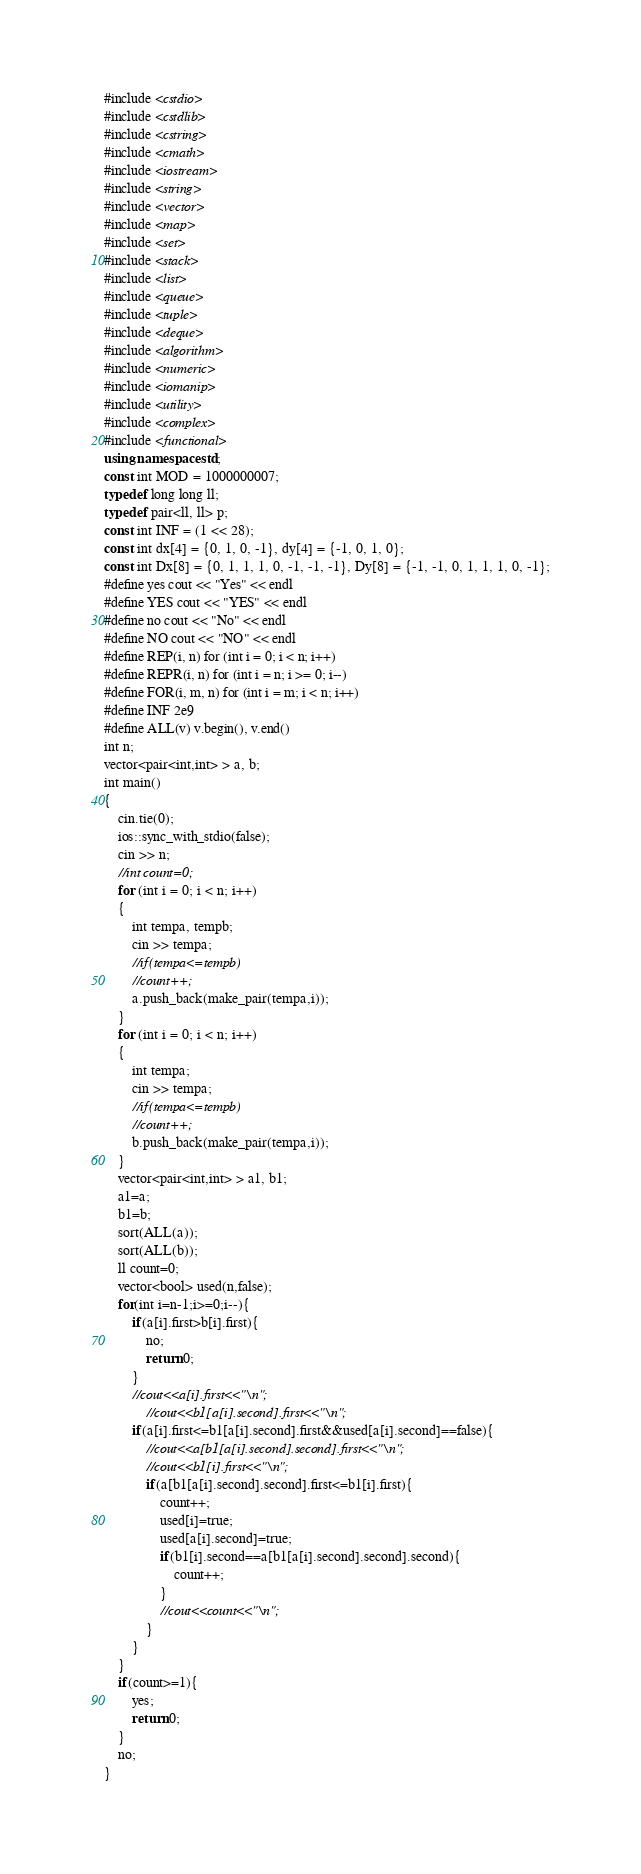Convert code to text. <code><loc_0><loc_0><loc_500><loc_500><_C++_>#include <cstdio>
#include <cstdlib>
#include <cstring>
#include <cmath>
#include <iostream>
#include <string>
#include <vector>
#include <map>
#include <set>
#include <stack>
#include <list>
#include <queue>
#include <tuple>
#include <deque>
#include <algorithm>
#include <numeric>
#include <iomanip>
#include <utility>
#include <complex>
#include <functional>
using namespace std;
const int MOD = 1000000007;
typedef long long ll;
typedef pair<ll, ll> p;
const int INF = (1 << 28);
const int dx[4] = {0, 1, 0, -1}, dy[4] = {-1, 0, 1, 0};
const int Dx[8] = {0, 1, 1, 1, 0, -1, -1, -1}, Dy[8] = {-1, -1, 0, 1, 1, 1, 0, -1};
#define yes cout << "Yes" << endl
#define YES cout << "YES" << endl
#define no cout << "No" << endl
#define NO cout << "NO" << endl
#define REP(i, n) for (int i = 0; i < n; i++)
#define REPR(i, n) for (int i = n; i >= 0; i--)
#define FOR(i, m, n) for (int i = m; i < n; i++)
#define INF 2e9
#define ALL(v) v.begin(), v.end()
int n;
vector<pair<int,int> > a, b;
int main()
{
    cin.tie(0);
    ios::sync_with_stdio(false);
    cin >> n;
    //int count=0;
    for (int i = 0; i < n; i++)
    {
        int tempa, tempb;
        cin >> tempa;
        //if(tempa<=tempb)
        //count++;
        a.push_back(make_pair(tempa,i));
    }
    for (int i = 0; i < n; i++)
    {
        int tempa;
        cin >> tempa;
        //if(tempa<=tempb)
        //count++;
        b.push_back(make_pair(tempa,i));
    }
    vector<pair<int,int> > a1, b1;
    a1=a;
    b1=b;
    sort(ALL(a));
    sort(ALL(b));
    ll count=0;
    vector<bool> used(n,false);
    for(int i=n-1;i>=0;i--){
        if(a[i].first>b[i].first){
            no;
            return 0;
        }
        //cout<<a[i].first<<"\n";
            //cout<<b1[a[i].second].first<<"\n";
        if(a[i].first<=b1[a[i].second].first&&used[a[i].second]==false){
            //cout<<a[b1[a[i].second].second].first<<"\n";
            //cout<<b1[i].first<<"\n";
            if(a[b1[a[i].second].second].first<=b1[i].first){
                count++;
                used[i]=true;
                used[a[i].second]=true;
                if(b1[i].second==a[b1[a[i].second].second].second){
                    count++;
                }
                //cout<<count<<"\n";
            }
        }
    }
    if(count>=1){
        yes;
        return 0;
    }
    no;
}
</code> 